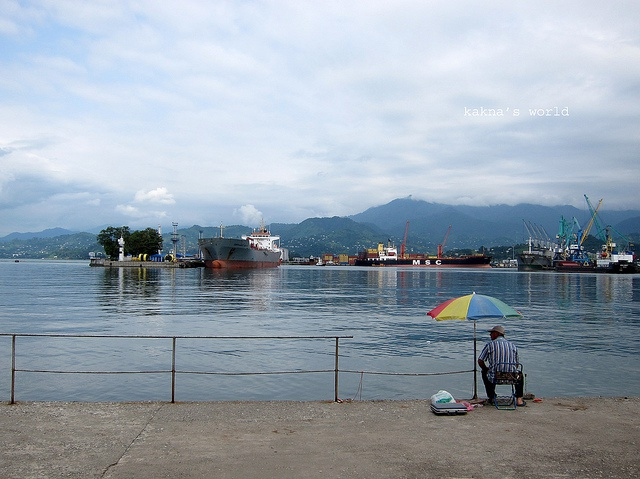Describe the objects in this image and their specific colors. I can see boat in lavender, black, gray, blue, and maroon tones, people in lavender, black, gray, navy, and darkgray tones, umbrella in lavender, gray, tan, and brown tones, chair in lavender, black, gray, and navy tones, and boat in lavender, black, gray, and blue tones in this image. 